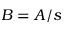Convert formula to latex. <formula><loc_0><loc_0><loc_500><loc_500>B = A / s</formula> 